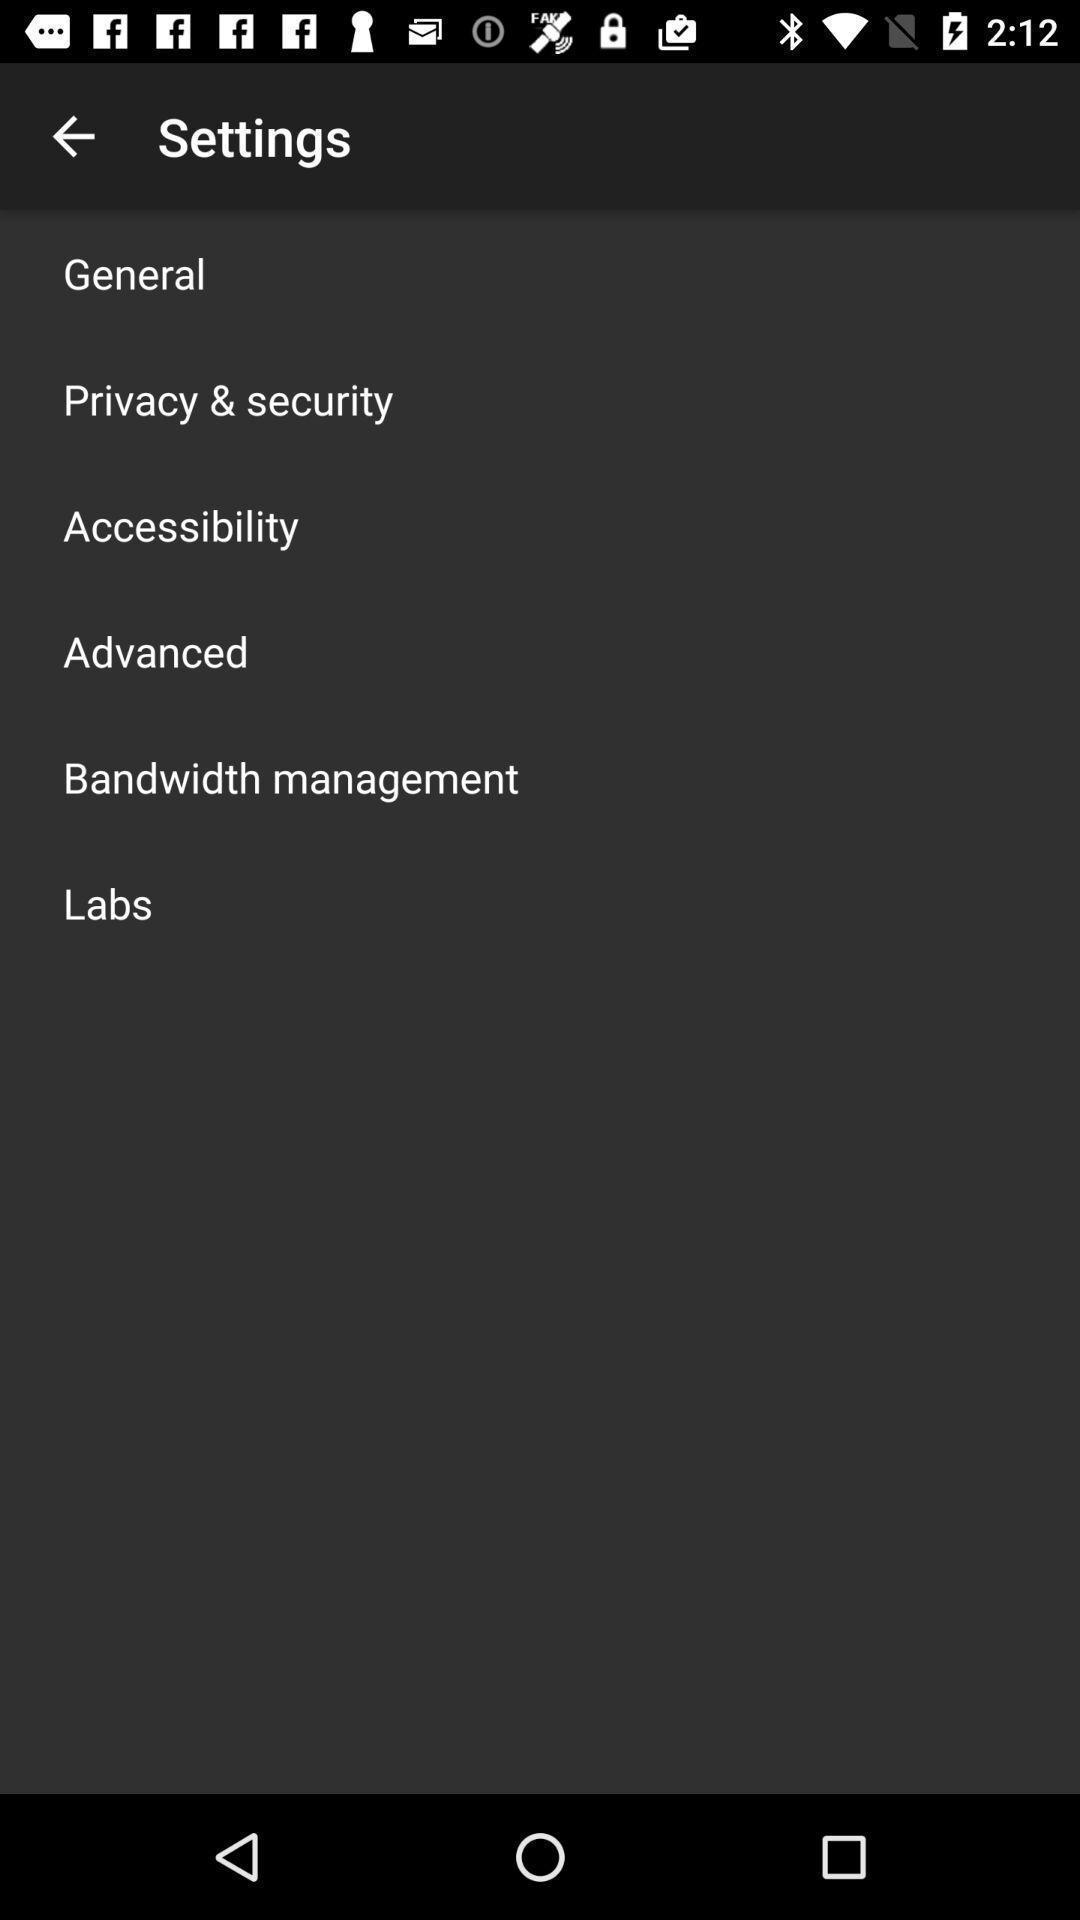Describe the visual elements of this screenshot. Settings page. 